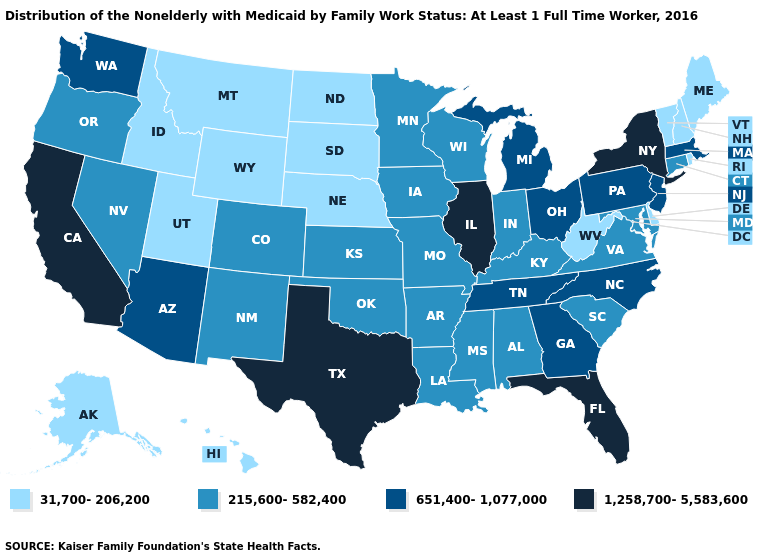What is the highest value in states that border Nevada?
Keep it brief. 1,258,700-5,583,600. Does Wyoming have the same value as Maryland?
Quick response, please. No. What is the value of Oklahoma?
Concise answer only. 215,600-582,400. Name the states that have a value in the range 215,600-582,400?
Concise answer only. Alabama, Arkansas, Colorado, Connecticut, Indiana, Iowa, Kansas, Kentucky, Louisiana, Maryland, Minnesota, Mississippi, Missouri, Nevada, New Mexico, Oklahoma, Oregon, South Carolina, Virginia, Wisconsin. What is the lowest value in states that border Indiana?
Give a very brief answer. 215,600-582,400. Among the states that border New Jersey , does New York have the highest value?
Give a very brief answer. Yes. Does Arizona have the highest value in the West?
Concise answer only. No. Name the states that have a value in the range 215,600-582,400?
Write a very short answer. Alabama, Arkansas, Colorado, Connecticut, Indiana, Iowa, Kansas, Kentucky, Louisiana, Maryland, Minnesota, Mississippi, Missouri, Nevada, New Mexico, Oklahoma, Oregon, South Carolina, Virginia, Wisconsin. Name the states that have a value in the range 1,258,700-5,583,600?
Keep it brief. California, Florida, Illinois, New York, Texas. Which states have the lowest value in the South?
Be succinct. Delaware, West Virginia. Name the states that have a value in the range 651,400-1,077,000?
Concise answer only. Arizona, Georgia, Massachusetts, Michigan, New Jersey, North Carolina, Ohio, Pennsylvania, Tennessee, Washington. Does North Carolina have a lower value than Maryland?
Give a very brief answer. No. What is the value of Minnesota?
Answer briefly. 215,600-582,400. What is the value of North Carolina?
Write a very short answer. 651,400-1,077,000. Does the map have missing data?
Be succinct. No. 